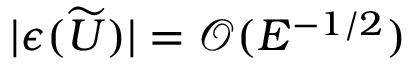Convert formula to latex. <formula><loc_0><loc_0><loc_500><loc_500>| \epsilon ( \widetilde { U } ) | = \mathcal { O } ( E ^ { - 1 / 2 } )</formula> 